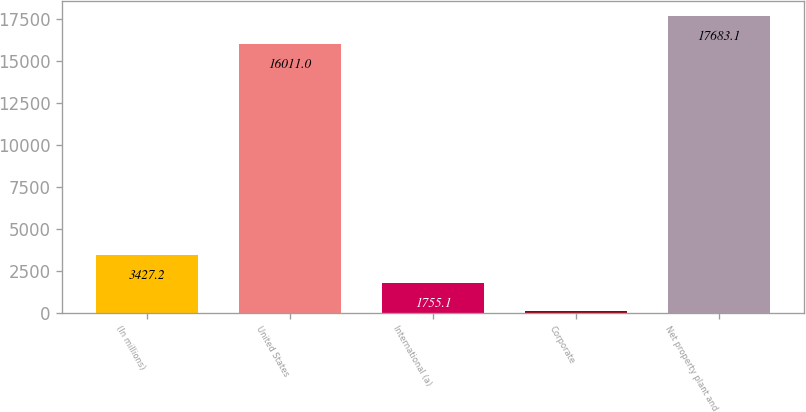<chart> <loc_0><loc_0><loc_500><loc_500><bar_chart><fcel>(In millions)<fcel>United States<fcel>International (a)<fcel>Corporate<fcel>Net property plant and<nl><fcel>3427.2<fcel>16011<fcel>1755.1<fcel>83<fcel>17683.1<nl></chart> 